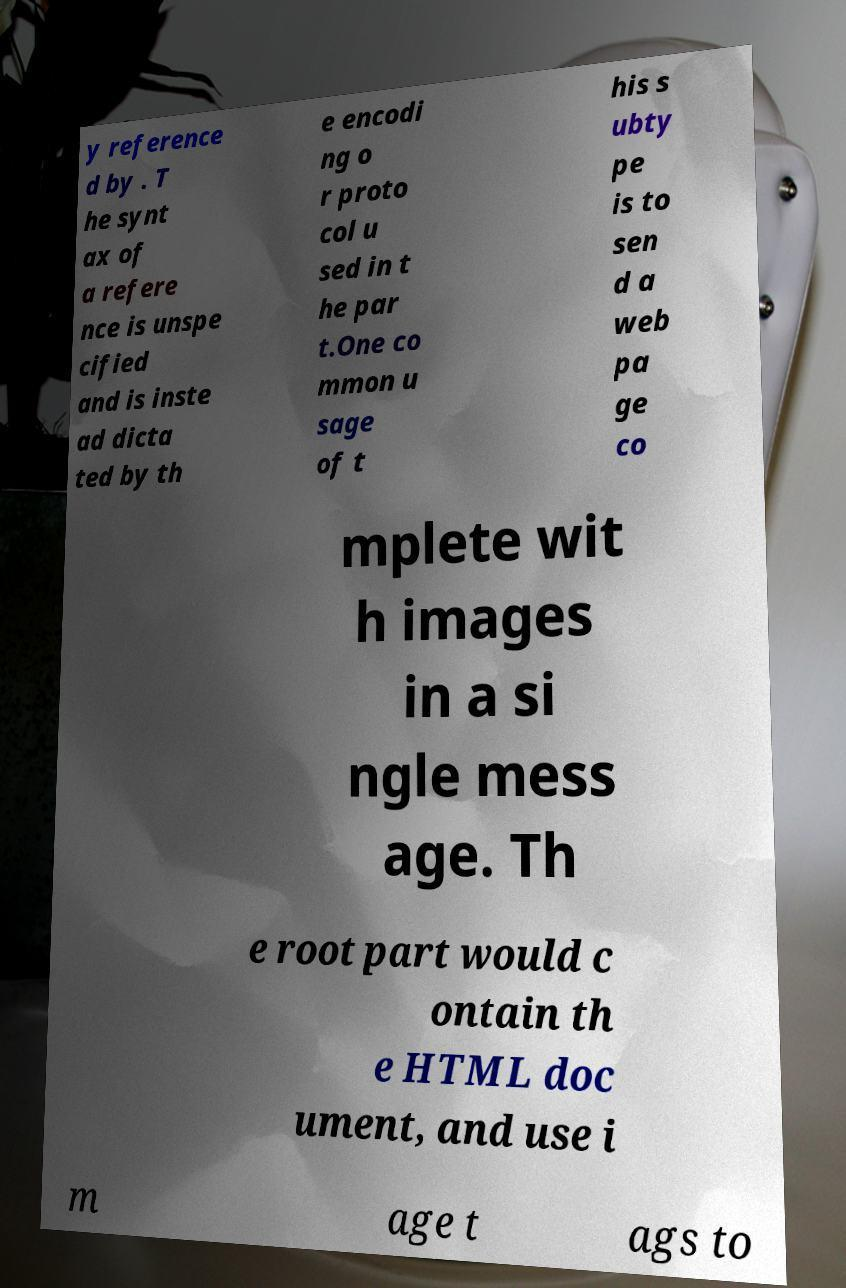Please read and relay the text visible in this image. What does it say? y reference d by . T he synt ax of a refere nce is unspe cified and is inste ad dicta ted by th e encodi ng o r proto col u sed in t he par t.One co mmon u sage of t his s ubty pe is to sen d a web pa ge co mplete wit h images in a si ngle mess age. Th e root part would c ontain th e HTML doc ument, and use i m age t ags to 